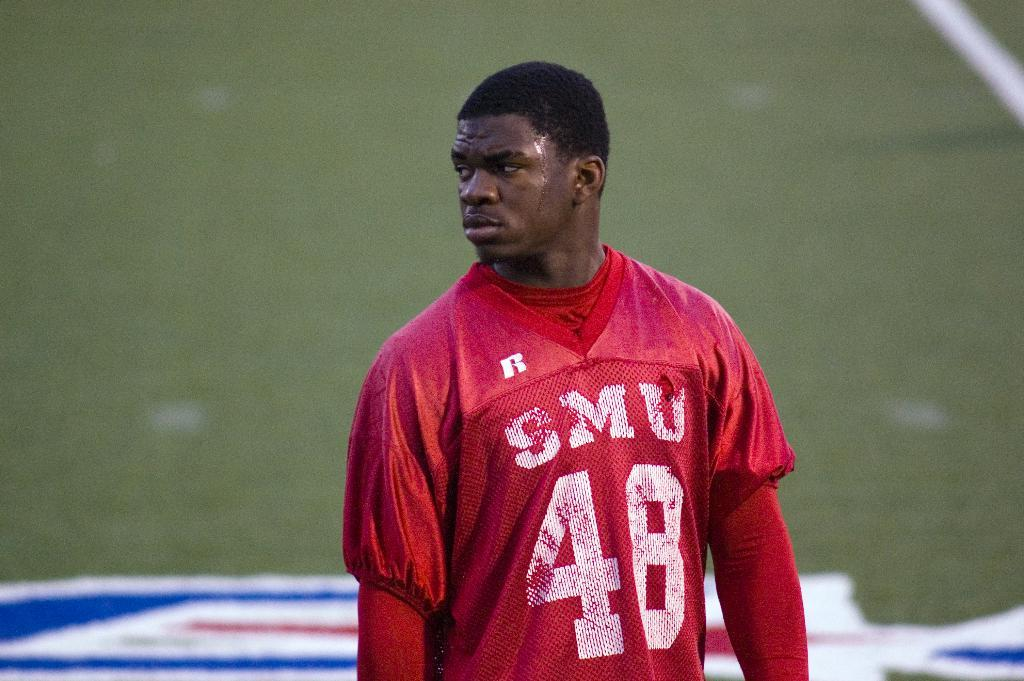<image>
Relay a brief, clear account of the picture shown. Player number 48 for SMU stands on an empty field 